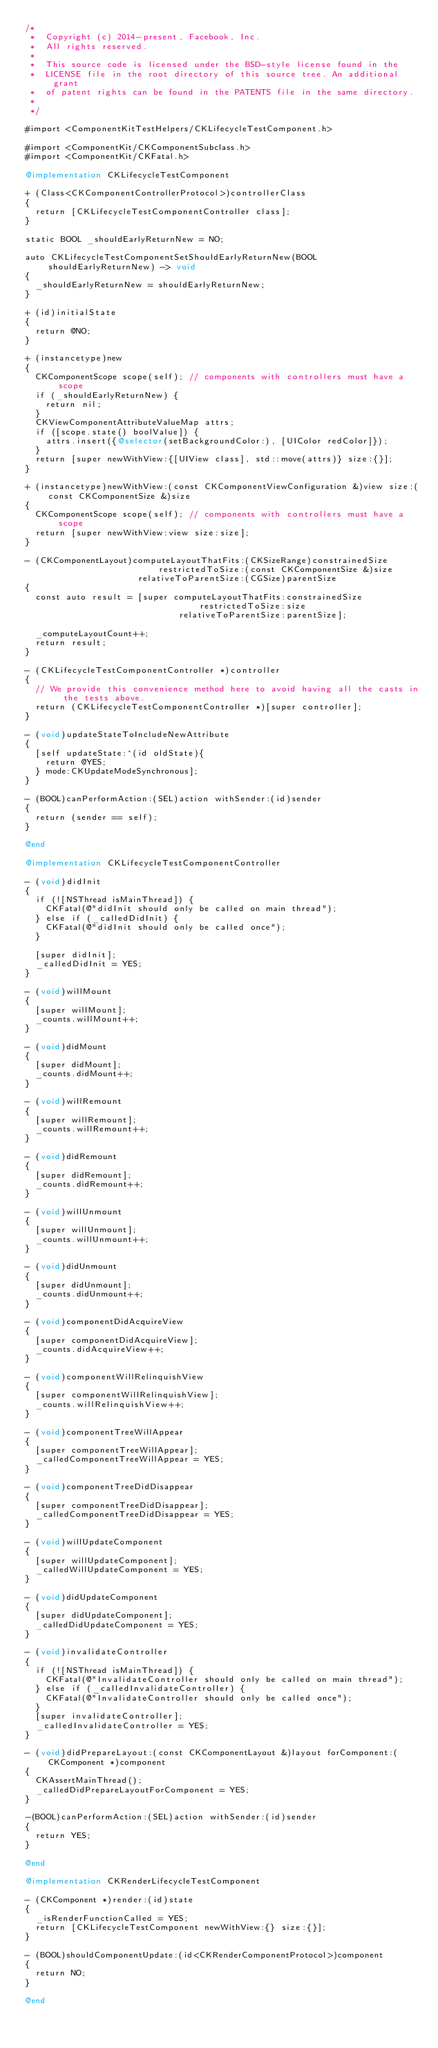<code> <loc_0><loc_0><loc_500><loc_500><_ObjectiveC_>/*
 *  Copyright (c) 2014-present, Facebook, Inc.
 *  All rights reserved.
 *
 *  This source code is licensed under the BSD-style license found in the
 *  LICENSE file in the root directory of this source tree. An additional grant
 *  of patent rights can be found in the PATENTS file in the same directory.
 *
 */

#import <ComponentKitTestHelpers/CKLifecycleTestComponent.h>

#import <ComponentKit/CKComponentSubclass.h>
#import <ComponentKit/CKFatal.h>

@implementation CKLifecycleTestComponent

+ (Class<CKComponentControllerProtocol>)controllerClass
{
  return [CKLifecycleTestComponentController class];
}

static BOOL _shouldEarlyReturnNew = NO;

auto CKLifecycleTestComponentSetShouldEarlyReturnNew(BOOL shouldEarlyReturnNew) -> void
{
  _shouldEarlyReturnNew = shouldEarlyReturnNew;
}

+ (id)initialState
{
  return @NO;
}

+ (instancetype)new
{
  CKComponentScope scope(self); // components with controllers must have a scope
  if (_shouldEarlyReturnNew) {
    return nil;
  }
  CKViewComponentAttributeValueMap attrs;
  if ([scope.state() boolValue]) {
    attrs.insert({@selector(setBackgroundColor:), [UIColor redColor]});
  }
  return [super newWithView:{[UIView class], std::move(attrs)} size:{}];
}

+ (instancetype)newWithView:(const CKComponentViewConfiguration &)view size:(const CKComponentSize &)size
{
  CKComponentScope scope(self); // components with controllers must have a scope
  return [super newWithView:view size:size];
}

- (CKComponentLayout)computeLayoutThatFits:(CKSizeRange)constrainedSize
                          restrictedToSize:(const CKComponentSize &)size
                      relativeToParentSize:(CGSize)parentSize
{
  const auto result = [super computeLayoutThatFits:constrainedSize
                                  restrictedToSize:size
                              relativeToParentSize:parentSize];

  _computeLayoutCount++;
  return result;
}

- (CKLifecycleTestComponentController *)controller
{
  // We provide this convenience method here to avoid having all the casts in the tests above.
  return (CKLifecycleTestComponentController *)[super controller];
}

- (void)updateStateToIncludeNewAttribute
{
  [self updateState:^(id oldState){
    return @YES;
  } mode:CKUpdateModeSynchronous];
}

- (BOOL)canPerformAction:(SEL)action withSender:(id)sender
{
  return (sender == self);
}

@end

@implementation CKLifecycleTestComponentController

- (void)didInit
{
  if (![NSThread isMainThread]) {
    CKFatal(@"didInit should only be called on main thread");
  } else if (_calledDidInit) {
    CKFatal(@"didInit should only be called once");
  }

  [super didInit];
  _calledDidInit = YES;
}

- (void)willMount
{
  [super willMount];
  _counts.willMount++;
}

- (void)didMount
{
  [super didMount];
  _counts.didMount++;
}

- (void)willRemount
{
  [super willRemount];
  _counts.willRemount++;
}

- (void)didRemount
{
  [super didRemount];
  _counts.didRemount++;
}

- (void)willUnmount
{
  [super willUnmount];
  _counts.willUnmount++;
}

- (void)didUnmount
{
  [super didUnmount];
  _counts.didUnmount++;
}

- (void)componentDidAcquireView
{
  [super componentDidAcquireView];
  _counts.didAcquireView++;
}

- (void)componentWillRelinquishView
{
  [super componentWillRelinquishView];
  _counts.willRelinquishView++;
}

- (void)componentTreeWillAppear
{
  [super componentTreeWillAppear];
  _calledComponentTreeWillAppear = YES;
}

- (void)componentTreeDidDisappear
{
  [super componentTreeDidDisappear];
  _calledComponentTreeDidDisappear = YES;
}

- (void)willUpdateComponent
{
  [super willUpdateComponent];
  _calledWillUpdateComponent = YES;
}

- (void)didUpdateComponent
{
  [super didUpdateComponent];
  _calledDidUpdateComponent = YES;
}

- (void)invalidateController
{
  if (![NSThread isMainThread]) {
    CKFatal(@"InvalidateController should only be called on main thread");
  } else if (_calledInvalidateController) {
    CKFatal(@"InvalidateController should only be called once");
  }
  [super invalidateController];
  _calledInvalidateController = YES;
}

- (void)didPrepareLayout:(const CKComponentLayout &)layout forComponent:(CKComponent *)component
{
  CKAssertMainThread();
  _calledDidPrepareLayoutForComponent = YES;
}

-(BOOL)canPerformAction:(SEL)action withSender:(id)sender
{
  return YES;
}

@end

@implementation CKRenderLifecycleTestComponent

- (CKComponent *)render:(id)state
{
  _isRenderFunctionCalled = YES;
  return [CKLifecycleTestComponent newWithView:{} size:{}];
}

- (BOOL)shouldComponentUpdate:(id<CKRenderComponentProtocol>)component
{
  return NO;
}

@end
</code> 